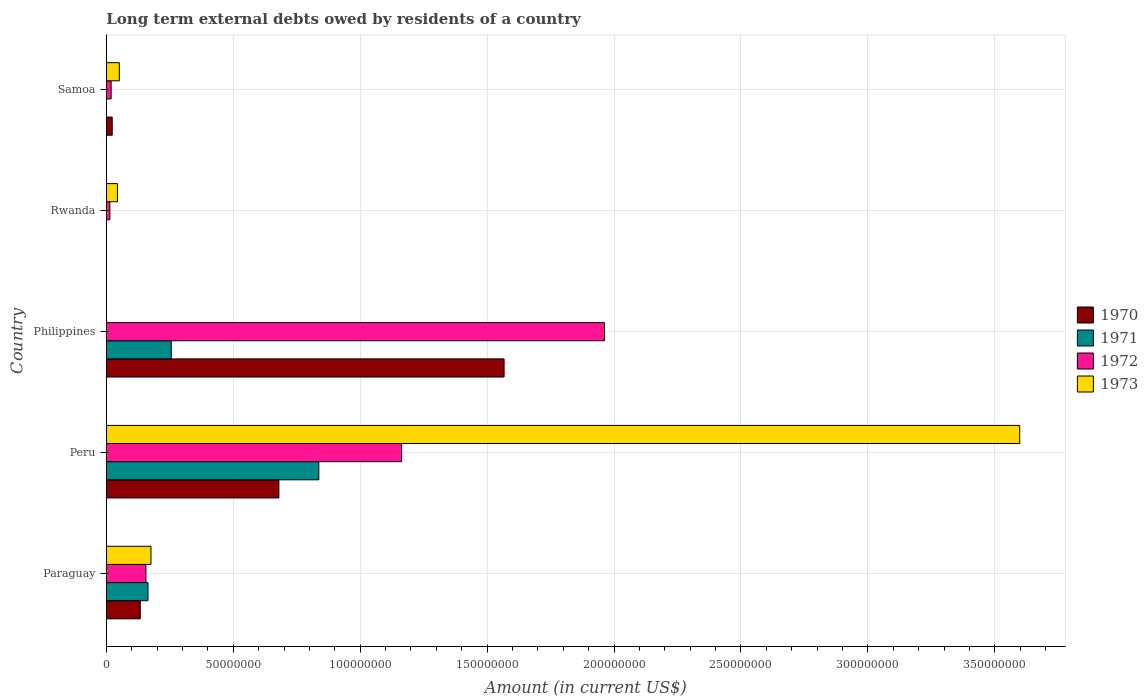How many groups of bars are there?
Your response must be concise. 5. Are the number of bars per tick equal to the number of legend labels?
Your answer should be compact. No. Are the number of bars on each tick of the Y-axis equal?
Make the answer very short. No. How many bars are there on the 4th tick from the top?
Offer a terse response. 4. What is the label of the 5th group of bars from the top?
Your answer should be compact. Paraguay. In how many cases, is the number of bars for a given country not equal to the number of legend labels?
Ensure brevity in your answer.  3. What is the amount of long-term external debts owed by residents in 1971 in Rwanda?
Your response must be concise. 0. Across all countries, what is the maximum amount of long-term external debts owed by residents in 1970?
Your answer should be compact. 1.57e+08. Across all countries, what is the minimum amount of long-term external debts owed by residents in 1972?
Offer a terse response. 1.39e+06. In which country was the amount of long-term external debts owed by residents in 1971 maximum?
Provide a short and direct response. Peru. What is the total amount of long-term external debts owed by residents in 1973 in the graph?
Provide a short and direct response. 3.87e+08. What is the difference between the amount of long-term external debts owed by residents in 1971 in Paraguay and that in Philippines?
Your answer should be very brief. -9.18e+06. What is the difference between the amount of long-term external debts owed by residents in 1972 in Rwanda and the amount of long-term external debts owed by residents in 1971 in Peru?
Your response must be concise. -8.23e+07. What is the average amount of long-term external debts owed by residents in 1970 per country?
Your answer should be compact. 4.81e+07. What is the difference between the amount of long-term external debts owed by residents in 1972 and amount of long-term external debts owed by residents in 1973 in Paraguay?
Offer a terse response. -2.00e+06. What is the ratio of the amount of long-term external debts owed by residents in 1970 in Philippines to that in Samoa?
Ensure brevity in your answer.  67.39. Is the amount of long-term external debts owed by residents in 1972 in Paraguay less than that in Rwanda?
Your answer should be compact. No. What is the difference between the highest and the second highest amount of long-term external debts owed by residents in 1972?
Your answer should be very brief. 7.99e+07. What is the difference between the highest and the lowest amount of long-term external debts owed by residents in 1973?
Give a very brief answer. 3.60e+08. How many bars are there?
Give a very brief answer. 16. Are all the bars in the graph horizontal?
Give a very brief answer. Yes. Are the values on the major ticks of X-axis written in scientific E-notation?
Your answer should be compact. No. Does the graph contain any zero values?
Ensure brevity in your answer.  Yes. Does the graph contain grids?
Offer a very short reply. Yes. Where does the legend appear in the graph?
Your answer should be very brief. Center right. How are the legend labels stacked?
Provide a succinct answer. Vertical. What is the title of the graph?
Offer a terse response. Long term external debts owed by residents of a country. Does "1961" appear as one of the legend labels in the graph?
Give a very brief answer. No. What is the label or title of the Y-axis?
Make the answer very short. Country. What is the Amount (in current US$) of 1970 in Paraguay?
Make the answer very short. 1.34e+07. What is the Amount (in current US$) of 1971 in Paraguay?
Ensure brevity in your answer.  1.64e+07. What is the Amount (in current US$) in 1972 in Paraguay?
Your answer should be compact. 1.56e+07. What is the Amount (in current US$) in 1973 in Paraguay?
Provide a succinct answer. 1.76e+07. What is the Amount (in current US$) in 1970 in Peru?
Keep it short and to the point. 6.80e+07. What is the Amount (in current US$) of 1971 in Peru?
Provide a short and direct response. 8.37e+07. What is the Amount (in current US$) in 1972 in Peru?
Ensure brevity in your answer.  1.16e+08. What is the Amount (in current US$) in 1973 in Peru?
Offer a terse response. 3.60e+08. What is the Amount (in current US$) of 1970 in Philippines?
Your answer should be compact. 1.57e+08. What is the Amount (in current US$) of 1971 in Philippines?
Your answer should be very brief. 2.56e+07. What is the Amount (in current US$) of 1972 in Philippines?
Make the answer very short. 1.96e+08. What is the Amount (in current US$) of 1971 in Rwanda?
Offer a terse response. 0. What is the Amount (in current US$) in 1972 in Rwanda?
Your answer should be very brief. 1.39e+06. What is the Amount (in current US$) of 1973 in Rwanda?
Ensure brevity in your answer.  4.37e+06. What is the Amount (in current US$) in 1970 in Samoa?
Ensure brevity in your answer.  2.32e+06. What is the Amount (in current US$) of 1971 in Samoa?
Keep it short and to the point. 0. What is the Amount (in current US$) of 1972 in Samoa?
Make the answer very short. 1.89e+06. What is the Amount (in current US$) of 1973 in Samoa?
Offer a terse response. 5.11e+06. Across all countries, what is the maximum Amount (in current US$) in 1970?
Your answer should be compact. 1.57e+08. Across all countries, what is the maximum Amount (in current US$) of 1971?
Keep it short and to the point. 8.37e+07. Across all countries, what is the maximum Amount (in current US$) of 1972?
Give a very brief answer. 1.96e+08. Across all countries, what is the maximum Amount (in current US$) of 1973?
Give a very brief answer. 3.60e+08. Across all countries, what is the minimum Amount (in current US$) in 1970?
Give a very brief answer. 0. Across all countries, what is the minimum Amount (in current US$) of 1972?
Offer a terse response. 1.39e+06. What is the total Amount (in current US$) in 1970 in the graph?
Keep it short and to the point. 2.40e+08. What is the total Amount (in current US$) in 1971 in the graph?
Ensure brevity in your answer.  1.26e+08. What is the total Amount (in current US$) of 1972 in the graph?
Make the answer very short. 3.31e+08. What is the total Amount (in current US$) in 1973 in the graph?
Ensure brevity in your answer.  3.87e+08. What is the difference between the Amount (in current US$) in 1970 in Paraguay and that in Peru?
Ensure brevity in your answer.  -5.46e+07. What is the difference between the Amount (in current US$) of 1971 in Paraguay and that in Peru?
Provide a short and direct response. -6.73e+07. What is the difference between the Amount (in current US$) in 1972 in Paraguay and that in Peru?
Ensure brevity in your answer.  -1.01e+08. What is the difference between the Amount (in current US$) of 1973 in Paraguay and that in Peru?
Give a very brief answer. -3.42e+08. What is the difference between the Amount (in current US$) in 1970 in Paraguay and that in Philippines?
Offer a terse response. -1.43e+08. What is the difference between the Amount (in current US$) in 1971 in Paraguay and that in Philippines?
Offer a very short reply. -9.18e+06. What is the difference between the Amount (in current US$) in 1972 in Paraguay and that in Philippines?
Offer a terse response. -1.81e+08. What is the difference between the Amount (in current US$) in 1972 in Paraguay and that in Rwanda?
Offer a terse response. 1.42e+07. What is the difference between the Amount (in current US$) in 1973 in Paraguay and that in Rwanda?
Offer a terse response. 1.32e+07. What is the difference between the Amount (in current US$) in 1970 in Paraguay and that in Samoa?
Provide a short and direct response. 1.10e+07. What is the difference between the Amount (in current US$) of 1972 in Paraguay and that in Samoa?
Ensure brevity in your answer.  1.37e+07. What is the difference between the Amount (in current US$) of 1973 in Paraguay and that in Samoa?
Provide a short and direct response. 1.25e+07. What is the difference between the Amount (in current US$) of 1970 in Peru and that in Philippines?
Your answer should be compact. -8.87e+07. What is the difference between the Amount (in current US$) of 1971 in Peru and that in Philippines?
Make the answer very short. 5.81e+07. What is the difference between the Amount (in current US$) in 1972 in Peru and that in Philippines?
Make the answer very short. -7.99e+07. What is the difference between the Amount (in current US$) in 1972 in Peru and that in Rwanda?
Your response must be concise. 1.15e+08. What is the difference between the Amount (in current US$) of 1973 in Peru and that in Rwanda?
Provide a short and direct response. 3.55e+08. What is the difference between the Amount (in current US$) in 1970 in Peru and that in Samoa?
Provide a succinct answer. 6.56e+07. What is the difference between the Amount (in current US$) in 1972 in Peru and that in Samoa?
Offer a very short reply. 1.14e+08. What is the difference between the Amount (in current US$) of 1973 in Peru and that in Samoa?
Provide a succinct answer. 3.55e+08. What is the difference between the Amount (in current US$) of 1972 in Philippines and that in Rwanda?
Make the answer very short. 1.95e+08. What is the difference between the Amount (in current US$) of 1970 in Philippines and that in Samoa?
Your answer should be very brief. 1.54e+08. What is the difference between the Amount (in current US$) in 1972 in Philippines and that in Samoa?
Your answer should be very brief. 1.94e+08. What is the difference between the Amount (in current US$) of 1972 in Rwanda and that in Samoa?
Your response must be concise. -5.01e+05. What is the difference between the Amount (in current US$) of 1973 in Rwanda and that in Samoa?
Give a very brief answer. -7.38e+05. What is the difference between the Amount (in current US$) in 1970 in Paraguay and the Amount (in current US$) in 1971 in Peru?
Provide a short and direct response. -7.03e+07. What is the difference between the Amount (in current US$) in 1970 in Paraguay and the Amount (in current US$) in 1972 in Peru?
Keep it short and to the point. -1.03e+08. What is the difference between the Amount (in current US$) in 1970 in Paraguay and the Amount (in current US$) in 1973 in Peru?
Give a very brief answer. -3.46e+08. What is the difference between the Amount (in current US$) of 1971 in Paraguay and the Amount (in current US$) of 1972 in Peru?
Offer a very short reply. -9.99e+07. What is the difference between the Amount (in current US$) in 1971 in Paraguay and the Amount (in current US$) in 1973 in Peru?
Give a very brief answer. -3.43e+08. What is the difference between the Amount (in current US$) of 1972 in Paraguay and the Amount (in current US$) of 1973 in Peru?
Provide a succinct answer. -3.44e+08. What is the difference between the Amount (in current US$) in 1970 in Paraguay and the Amount (in current US$) in 1971 in Philippines?
Provide a short and direct response. -1.22e+07. What is the difference between the Amount (in current US$) in 1970 in Paraguay and the Amount (in current US$) in 1972 in Philippines?
Offer a terse response. -1.83e+08. What is the difference between the Amount (in current US$) in 1971 in Paraguay and the Amount (in current US$) in 1972 in Philippines?
Keep it short and to the point. -1.80e+08. What is the difference between the Amount (in current US$) of 1970 in Paraguay and the Amount (in current US$) of 1972 in Rwanda?
Offer a very short reply. 1.20e+07. What is the difference between the Amount (in current US$) in 1970 in Paraguay and the Amount (in current US$) in 1973 in Rwanda?
Your answer should be compact. 8.99e+06. What is the difference between the Amount (in current US$) of 1971 in Paraguay and the Amount (in current US$) of 1972 in Rwanda?
Keep it short and to the point. 1.50e+07. What is the difference between the Amount (in current US$) in 1971 in Paraguay and the Amount (in current US$) in 1973 in Rwanda?
Offer a very short reply. 1.20e+07. What is the difference between the Amount (in current US$) of 1972 in Paraguay and the Amount (in current US$) of 1973 in Rwanda?
Provide a succinct answer. 1.12e+07. What is the difference between the Amount (in current US$) in 1970 in Paraguay and the Amount (in current US$) in 1972 in Samoa?
Offer a terse response. 1.15e+07. What is the difference between the Amount (in current US$) in 1970 in Paraguay and the Amount (in current US$) in 1973 in Samoa?
Make the answer very short. 8.25e+06. What is the difference between the Amount (in current US$) of 1971 in Paraguay and the Amount (in current US$) of 1972 in Samoa?
Keep it short and to the point. 1.45e+07. What is the difference between the Amount (in current US$) in 1971 in Paraguay and the Amount (in current US$) in 1973 in Samoa?
Give a very brief answer. 1.13e+07. What is the difference between the Amount (in current US$) of 1972 in Paraguay and the Amount (in current US$) of 1973 in Samoa?
Keep it short and to the point. 1.05e+07. What is the difference between the Amount (in current US$) in 1970 in Peru and the Amount (in current US$) in 1971 in Philippines?
Give a very brief answer. 4.24e+07. What is the difference between the Amount (in current US$) of 1970 in Peru and the Amount (in current US$) of 1972 in Philippines?
Your answer should be compact. -1.28e+08. What is the difference between the Amount (in current US$) of 1971 in Peru and the Amount (in current US$) of 1972 in Philippines?
Offer a very short reply. -1.13e+08. What is the difference between the Amount (in current US$) in 1970 in Peru and the Amount (in current US$) in 1972 in Rwanda?
Provide a short and direct response. 6.66e+07. What is the difference between the Amount (in current US$) in 1970 in Peru and the Amount (in current US$) in 1973 in Rwanda?
Give a very brief answer. 6.36e+07. What is the difference between the Amount (in current US$) in 1971 in Peru and the Amount (in current US$) in 1972 in Rwanda?
Your answer should be very brief. 8.23e+07. What is the difference between the Amount (in current US$) of 1971 in Peru and the Amount (in current US$) of 1973 in Rwanda?
Your answer should be very brief. 7.93e+07. What is the difference between the Amount (in current US$) of 1972 in Peru and the Amount (in current US$) of 1973 in Rwanda?
Ensure brevity in your answer.  1.12e+08. What is the difference between the Amount (in current US$) of 1970 in Peru and the Amount (in current US$) of 1972 in Samoa?
Ensure brevity in your answer.  6.61e+07. What is the difference between the Amount (in current US$) of 1970 in Peru and the Amount (in current US$) of 1973 in Samoa?
Your answer should be compact. 6.29e+07. What is the difference between the Amount (in current US$) in 1971 in Peru and the Amount (in current US$) in 1972 in Samoa?
Your answer should be compact. 8.18e+07. What is the difference between the Amount (in current US$) of 1971 in Peru and the Amount (in current US$) of 1973 in Samoa?
Your answer should be compact. 7.86e+07. What is the difference between the Amount (in current US$) in 1972 in Peru and the Amount (in current US$) in 1973 in Samoa?
Offer a very short reply. 1.11e+08. What is the difference between the Amount (in current US$) of 1970 in Philippines and the Amount (in current US$) of 1972 in Rwanda?
Make the answer very short. 1.55e+08. What is the difference between the Amount (in current US$) of 1970 in Philippines and the Amount (in current US$) of 1973 in Rwanda?
Give a very brief answer. 1.52e+08. What is the difference between the Amount (in current US$) in 1971 in Philippines and the Amount (in current US$) in 1972 in Rwanda?
Make the answer very short. 2.42e+07. What is the difference between the Amount (in current US$) of 1971 in Philippines and the Amount (in current US$) of 1973 in Rwanda?
Ensure brevity in your answer.  2.12e+07. What is the difference between the Amount (in current US$) in 1972 in Philippines and the Amount (in current US$) in 1973 in Rwanda?
Give a very brief answer. 1.92e+08. What is the difference between the Amount (in current US$) in 1970 in Philippines and the Amount (in current US$) in 1972 in Samoa?
Keep it short and to the point. 1.55e+08. What is the difference between the Amount (in current US$) in 1970 in Philippines and the Amount (in current US$) in 1973 in Samoa?
Provide a short and direct response. 1.52e+08. What is the difference between the Amount (in current US$) of 1971 in Philippines and the Amount (in current US$) of 1972 in Samoa?
Give a very brief answer. 2.37e+07. What is the difference between the Amount (in current US$) of 1971 in Philippines and the Amount (in current US$) of 1973 in Samoa?
Make the answer very short. 2.05e+07. What is the difference between the Amount (in current US$) of 1972 in Philippines and the Amount (in current US$) of 1973 in Samoa?
Offer a very short reply. 1.91e+08. What is the difference between the Amount (in current US$) in 1972 in Rwanda and the Amount (in current US$) in 1973 in Samoa?
Your response must be concise. -3.72e+06. What is the average Amount (in current US$) of 1970 per country?
Keep it short and to the point. 4.81e+07. What is the average Amount (in current US$) in 1971 per country?
Ensure brevity in your answer.  2.51e+07. What is the average Amount (in current US$) in 1972 per country?
Keep it short and to the point. 6.63e+07. What is the average Amount (in current US$) in 1973 per country?
Give a very brief answer. 7.74e+07. What is the difference between the Amount (in current US$) in 1970 and Amount (in current US$) in 1971 in Paraguay?
Make the answer very short. -3.05e+06. What is the difference between the Amount (in current US$) of 1970 and Amount (in current US$) of 1972 in Paraguay?
Provide a succinct answer. -2.23e+06. What is the difference between the Amount (in current US$) of 1970 and Amount (in current US$) of 1973 in Paraguay?
Offer a very short reply. -4.23e+06. What is the difference between the Amount (in current US$) of 1971 and Amount (in current US$) of 1972 in Paraguay?
Provide a short and direct response. 8.15e+05. What is the difference between the Amount (in current US$) in 1971 and Amount (in current US$) in 1973 in Paraguay?
Provide a succinct answer. -1.18e+06. What is the difference between the Amount (in current US$) of 1972 and Amount (in current US$) of 1973 in Paraguay?
Keep it short and to the point. -2.00e+06. What is the difference between the Amount (in current US$) in 1970 and Amount (in current US$) in 1971 in Peru?
Keep it short and to the point. -1.57e+07. What is the difference between the Amount (in current US$) in 1970 and Amount (in current US$) in 1972 in Peru?
Offer a terse response. -4.83e+07. What is the difference between the Amount (in current US$) of 1970 and Amount (in current US$) of 1973 in Peru?
Give a very brief answer. -2.92e+08. What is the difference between the Amount (in current US$) of 1971 and Amount (in current US$) of 1972 in Peru?
Make the answer very short. -3.26e+07. What is the difference between the Amount (in current US$) in 1971 and Amount (in current US$) in 1973 in Peru?
Ensure brevity in your answer.  -2.76e+08. What is the difference between the Amount (in current US$) in 1972 and Amount (in current US$) in 1973 in Peru?
Give a very brief answer. -2.43e+08. What is the difference between the Amount (in current US$) in 1970 and Amount (in current US$) in 1971 in Philippines?
Keep it short and to the point. 1.31e+08. What is the difference between the Amount (in current US$) in 1970 and Amount (in current US$) in 1972 in Philippines?
Offer a terse response. -3.96e+07. What is the difference between the Amount (in current US$) in 1971 and Amount (in current US$) in 1972 in Philippines?
Provide a short and direct response. -1.71e+08. What is the difference between the Amount (in current US$) of 1972 and Amount (in current US$) of 1973 in Rwanda?
Your response must be concise. -2.98e+06. What is the difference between the Amount (in current US$) in 1970 and Amount (in current US$) in 1972 in Samoa?
Provide a succinct answer. 4.36e+05. What is the difference between the Amount (in current US$) in 1970 and Amount (in current US$) in 1973 in Samoa?
Ensure brevity in your answer.  -2.79e+06. What is the difference between the Amount (in current US$) of 1972 and Amount (in current US$) of 1973 in Samoa?
Your response must be concise. -3.22e+06. What is the ratio of the Amount (in current US$) of 1970 in Paraguay to that in Peru?
Keep it short and to the point. 0.2. What is the ratio of the Amount (in current US$) of 1971 in Paraguay to that in Peru?
Your answer should be very brief. 0.2. What is the ratio of the Amount (in current US$) in 1972 in Paraguay to that in Peru?
Make the answer very short. 0.13. What is the ratio of the Amount (in current US$) in 1973 in Paraguay to that in Peru?
Provide a short and direct response. 0.05. What is the ratio of the Amount (in current US$) in 1970 in Paraguay to that in Philippines?
Offer a terse response. 0.09. What is the ratio of the Amount (in current US$) of 1971 in Paraguay to that in Philippines?
Offer a terse response. 0.64. What is the ratio of the Amount (in current US$) in 1972 in Paraguay to that in Philippines?
Provide a short and direct response. 0.08. What is the ratio of the Amount (in current US$) in 1972 in Paraguay to that in Rwanda?
Provide a succinct answer. 11.23. What is the ratio of the Amount (in current US$) in 1973 in Paraguay to that in Rwanda?
Make the answer very short. 4.02. What is the ratio of the Amount (in current US$) in 1970 in Paraguay to that in Samoa?
Provide a short and direct response. 5.75. What is the ratio of the Amount (in current US$) of 1972 in Paraguay to that in Samoa?
Your response must be concise. 8.25. What is the ratio of the Amount (in current US$) of 1973 in Paraguay to that in Samoa?
Provide a short and direct response. 3.44. What is the ratio of the Amount (in current US$) in 1970 in Peru to that in Philippines?
Provide a short and direct response. 0.43. What is the ratio of the Amount (in current US$) of 1971 in Peru to that in Philippines?
Your response must be concise. 3.27. What is the ratio of the Amount (in current US$) of 1972 in Peru to that in Philippines?
Ensure brevity in your answer.  0.59. What is the ratio of the Amount (in current US$) in 1972 in Peru to that in Rwanda?
Your response must be concise. 83.8. What is the ratio of the Amount (in current US$) in 1973 in Peru to that in Rwanda?
Provide a succinct answer. 82.28. What is the ratio of the Amount (in current US$) in 1970 in Peru to that in Samoa?
Offer a terse response. 29.23. What is the ratio of the Amount (in current US$) in 1972 in Peru to that in Samoa?
Ensure brevity in your answer.  61.58. What is the ratio of the Amount (in current US$) in 1973 in Peru to that in Samoa?
Ensure brevity in your answer.  70.4. What is the ratio of the Amount (in current US$) in 1972 in Philippines to that in Rwanda?
Your response must be concise. 141.39. What is the ratio of the Amount (in current US$) in 1970 in Philippines to that in Samoa?
Make the answer very short. 67.39. What is the ratio of the Amount (in current US$) in 1972 in Philippines to that in Samoa?
Offer a terse response. 103.89. What is the ratio of the Amount (in current US$) in 1972 in Rwanda to that in Samoa?
Keep it short and to the point. 0.73. What is the ratio of the Amount (in current US$) of 1973 in Rwanda to that in Samoa?
Your answer should be very brief. 0.86. What is the difference between the highest and the second highest Amount (in current US$) of 1970?
Provide a succinct answer. 8.87e+07. What is the difference between the highest and the second highest Amount (in current US$) in 1971?
Your answer should be compact. 5.81e+07. What is the difference between the highest and the second highest Amount (in current US$) in 1972?
Offer a very short reply. 7.99e+07. What is the difference between the highest and the second highest Amount (in current US$) of 1973?
Your answer should be very brief. 3.42e+08. What is the difference between the highest and the lowest Amount (in current US$) in 1970?
Give a very brief answer. 1.57e+08. What is the difference between the highest and the lowest Amount (in current US$) of 1971?
Offer a terse response. 8.37e+07. What is the difference between the highest and the lowest Amount (in current US$) of 1972?
Your response must be concise. 1.95e+08. What is the difference between the highest and the lowest Amount (in current US$) in 1973?
Provide a succinct answer. 3.60e+08. 